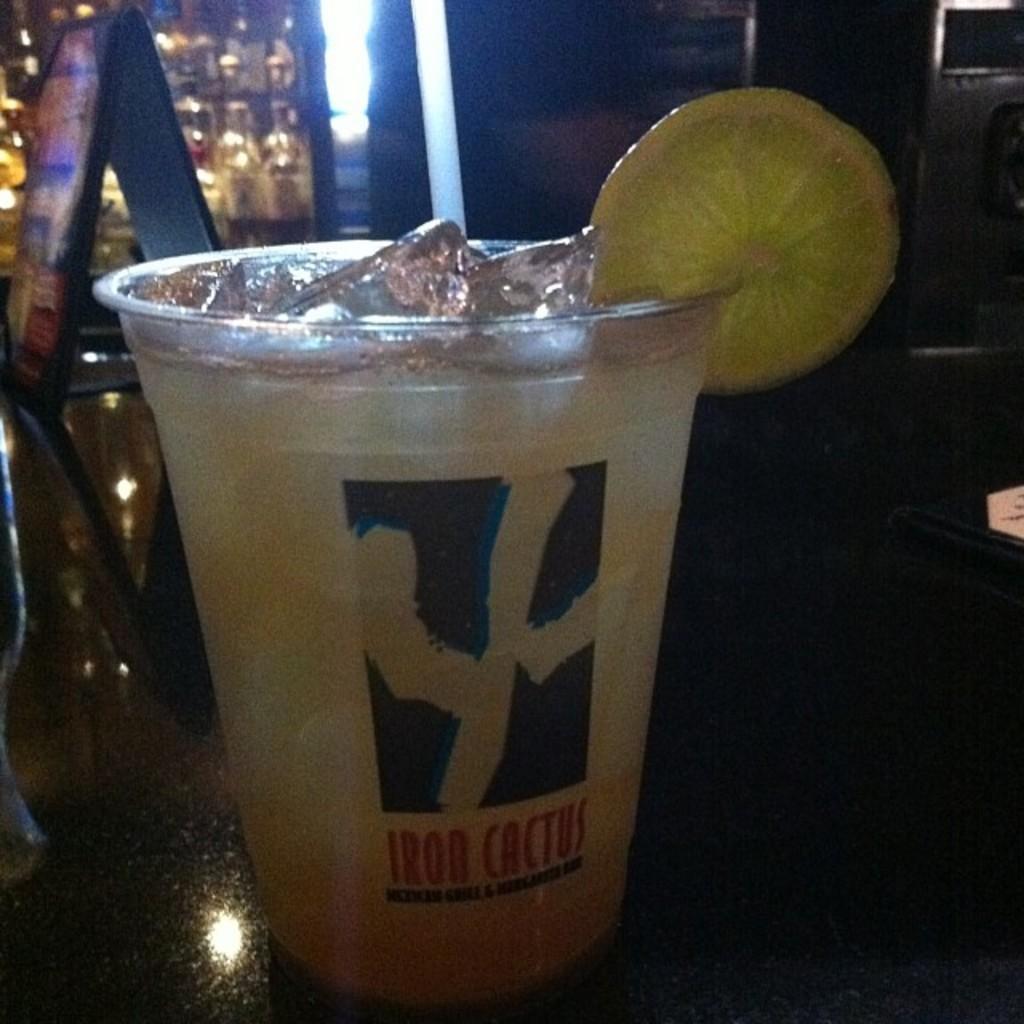Can you describe this image briefly? In the center of the image there is a beverage and lemon placed in a glass placed on the table. 